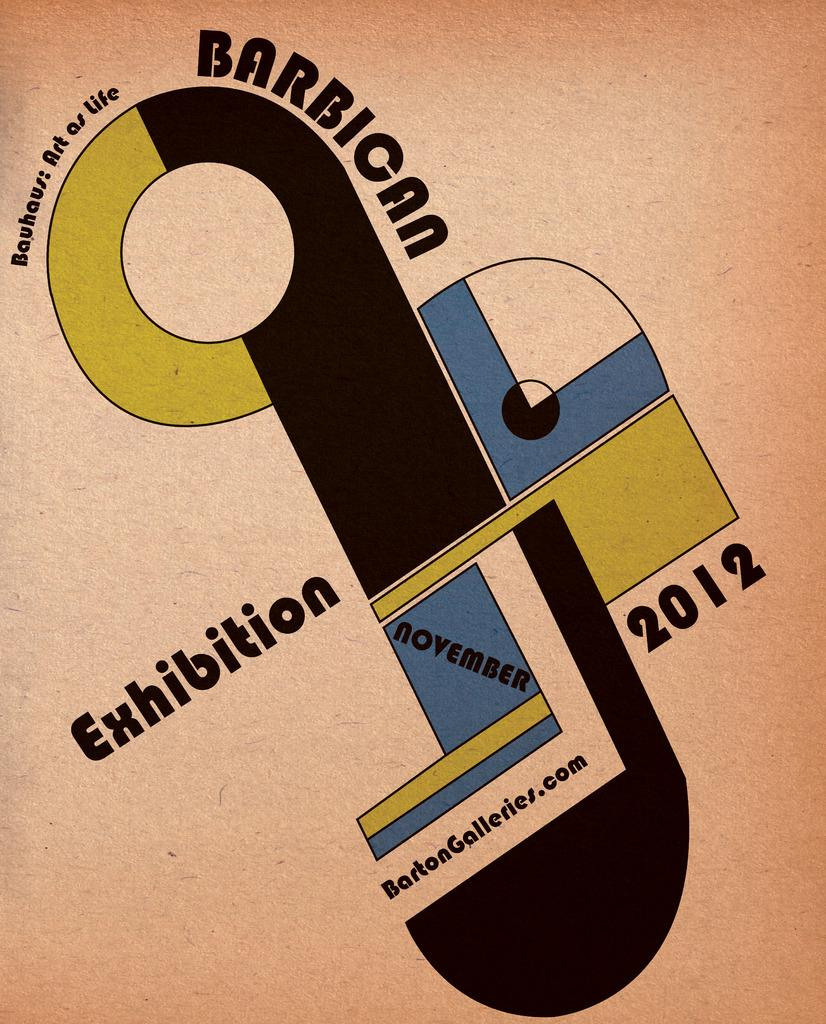<image>
Share a concise interpretation of the image provided. a paper that says 'barbioan exhibition 2012' on it 